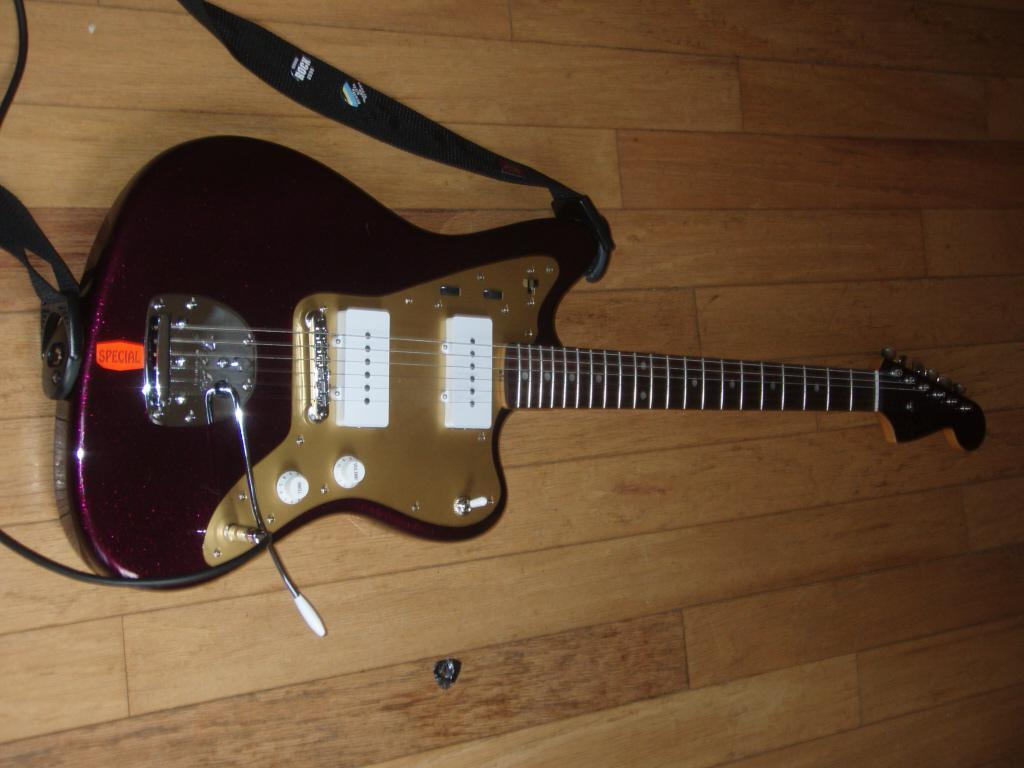What is the main object in the foreground of the image? There is a guitar in the foreground area of the image. What type of chicken is sitting on the board in the image? There is no chicken or board present in the image; it only features a guitar in the foreground. 